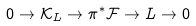Convert formula to latex. <formula><loc_0><loc_0><loc_500><loc_500>0 \rightarrow \mathcal { K } _ { L } \rightarrow \pi ^ { * } \mathcal { F } \rightarrow L \rightarrow 0</formula> 